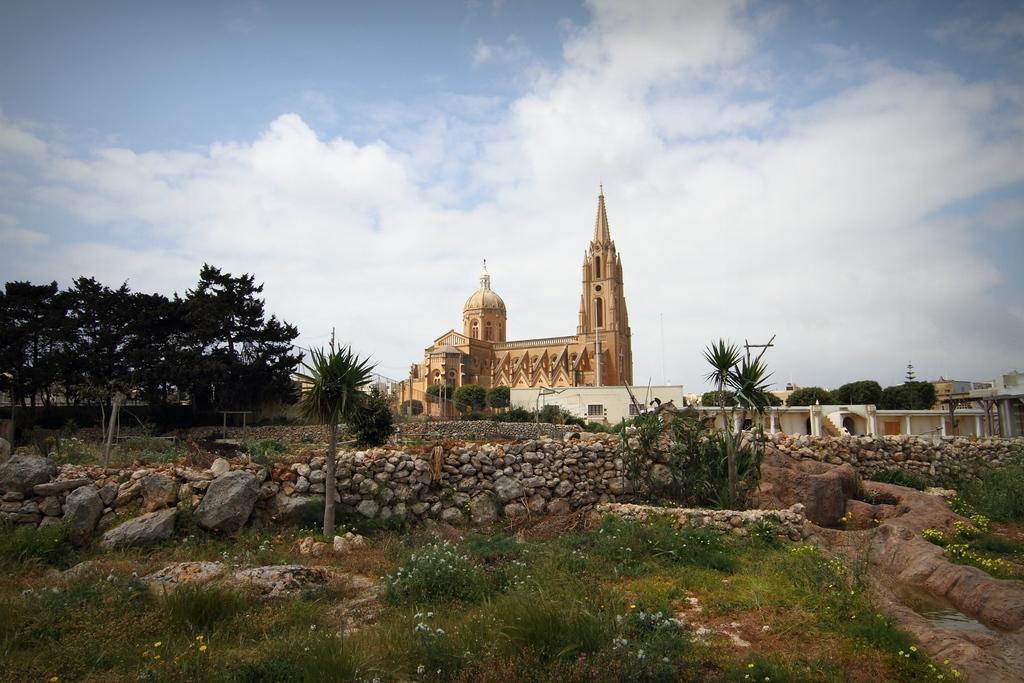What type of structures can be seen in the image? There are buildings in the image. What architectural feature is present in the image? There are stairs in the image. What natural elements can be seen in the image? There are trees, water, rocks, and grass in the image. What is the color of the sky in the image? The sky is blue and white in color. What type of patch is sewn onto the apparel of the person in the image? There is no person present in the image, and therefore no apparel or patches can be observed. What time of day is depicted in the image? The provided facts do not mention the time of day, so it cannot be determined from the image. 